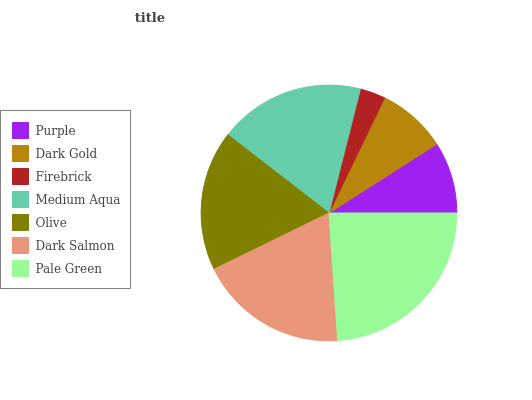Is Firebrick the minimum?
Answer yes or no. Yes. Is Pale Green the maximum?
Answer yes or no. Yes. Is Dark Gold the minimum?
Answer yes or no. No. Is Dark Gold the maximum?
Answer yes or no. No. Is Purple greater than Dark Gold?
Answer yes or no. Yes. Is Dark Gold less than Purple?
Answer yes or no. Yes. Is Dark Gold greater than Purple?
Answer yes or no. No. Is Purple less than Dark Gold?
Answer yes or no. No. Is Olive the high median?
Answer yes or no. Yes. Is Olive the low median?
Answer yes or no. Yes. Is Medium Aqua the high median?
Answer yes or no. No. Is Purple the low median?
Answer yes or no. No. 